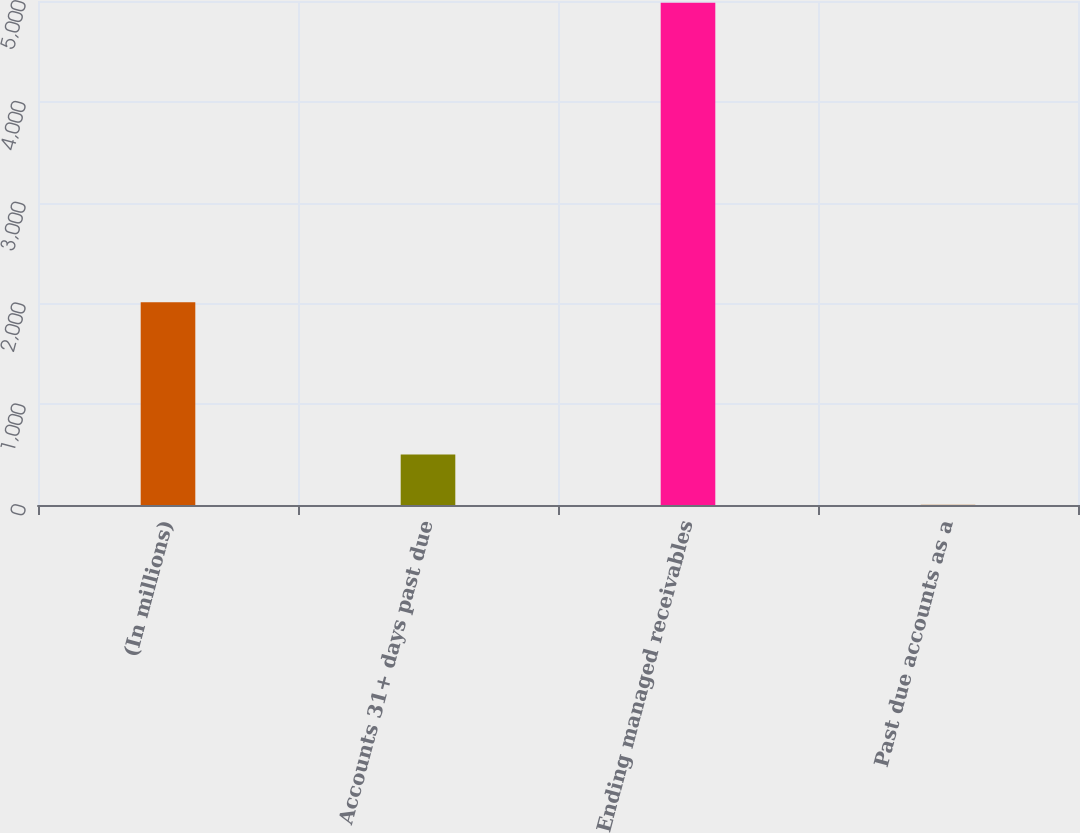Convert chart to OTSL. <chart><loc_0><loc_0><loc_500><loc_500><bar_chart><fcel>(In millions)<fcel>Accounts 31+ days past due<fcel>Ending managed receivables<fcel>Past due accounts as a<nl><fcel>2012<fcel>500.29<fcel>4981.8<fcel>2.34<nl></chart> 